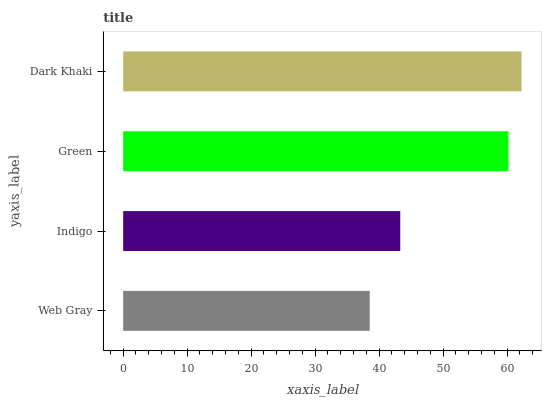Is Web Gray the minimum?
Answer yes or no. Yes. Is Dark Khaki the maximum?
Answer yes or no. Yes. Is Indigo the minimum?
Answer yes or no. No. Is Indigo the maximum?
Answer yes or no. No. Is Indigo greater than Web Gray?
Answer yes or no. Yes. Is Web Gray less than Indigo?
Answer yes or no. Yes. Is Web Gray greater than Indigo?
Answer yes or no. No. Is Indigo less than Web Gray?
Answer yes or no. No. Is Green the high median?
Answer yes or no. Yes. Is Indigo the low median?
Answer yes or no. Yes. Is Indigo the high median?
Answer yes or no. No. Is Web Gray the low median?
Answer yes or no. No. 